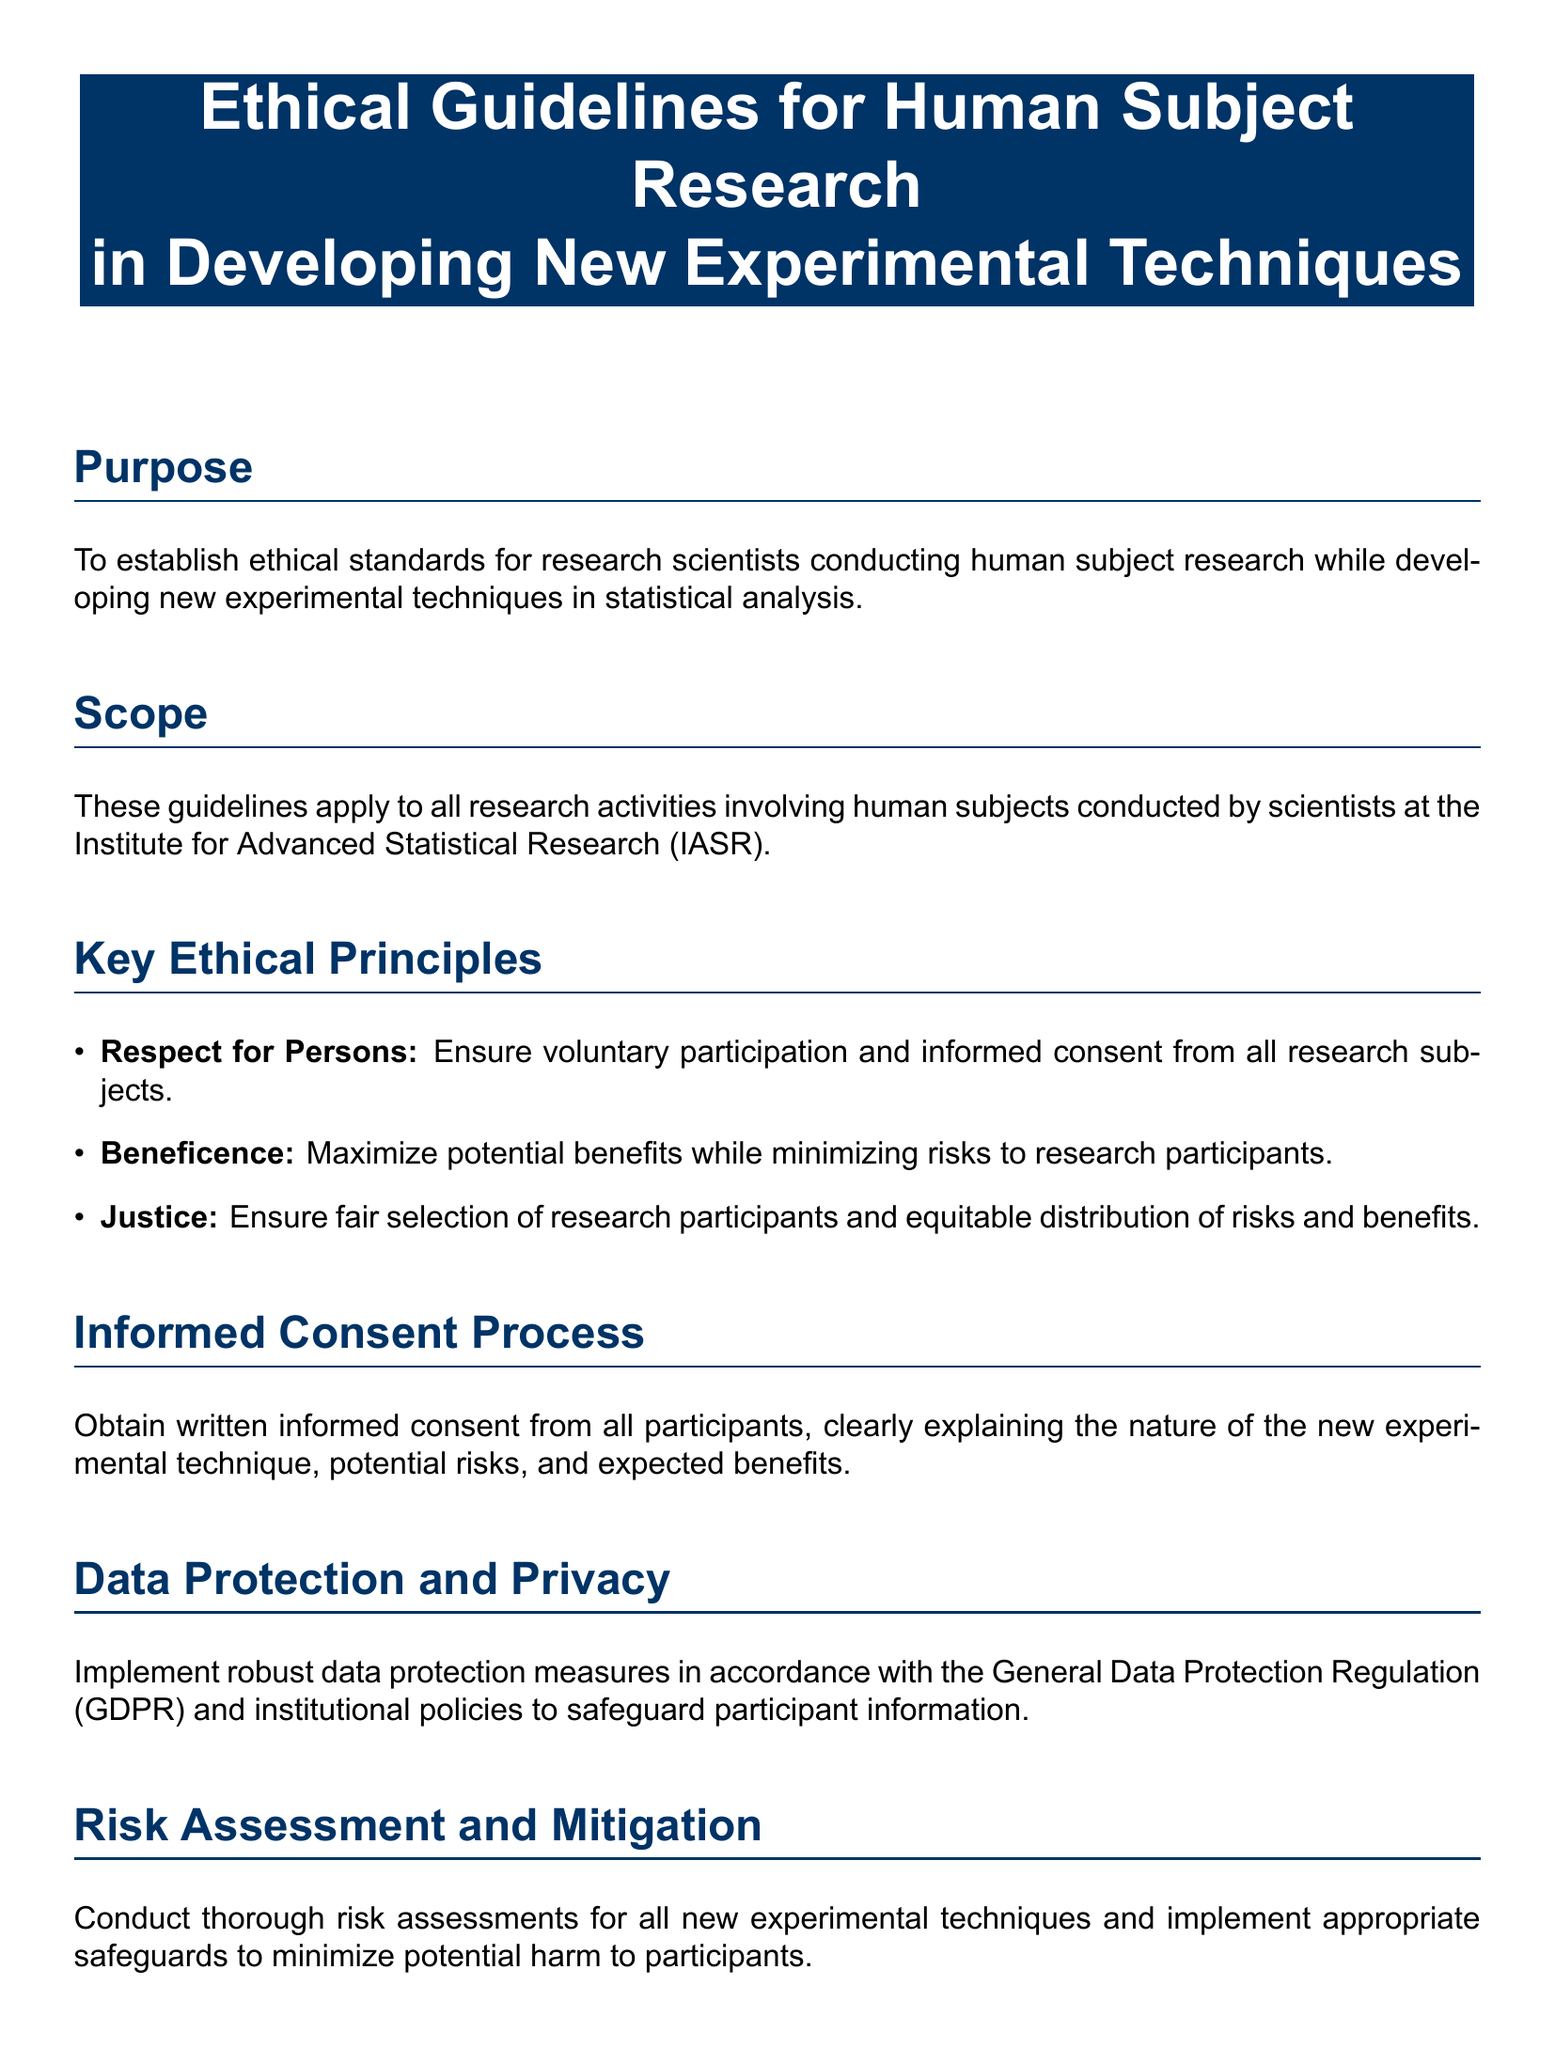What is the title of the document? The title is presented at the top of the document as a central element.
Answer: Ethical Guidelines for Human Subject Research in Developing New Experimental Techniques What organization do these guidelines apply to? The scope section mentions the organization that these guidelines apply to.
Answer: Institute for Advanced Statistical Research (IASR) What is one of the key ethical principles listed? The key ethical principles are clearly enumerated in the document's section dedicated to them.
Answer: Respect for Persons What must participants provide according to the informed consent process? The informed consent process section specifies what is required from participants before taking part in the research.
Answer: Written informed consent What regulation must data protection measures comply with? The section on data protection mentions a specific regulation that must be followed.
Answer: General Data Protection Regulation (GDPR) What is required before commencing human subject research? The ethical review process outlines a necessary step before beginning research activities.
Answer: Approval from the IASR Institutional Review Board (IRB) What should be established for ongoing oversight of research activities? The document highlights the importance of a certain system in the reporting and monitoring section.
Answer: A system for ongoing monitoring What is the main purpose of these guidelines? The purpose section briefly explains the primary intention behind the creation of these guidelines.
Answer: To establish ethical standards for research scientists 